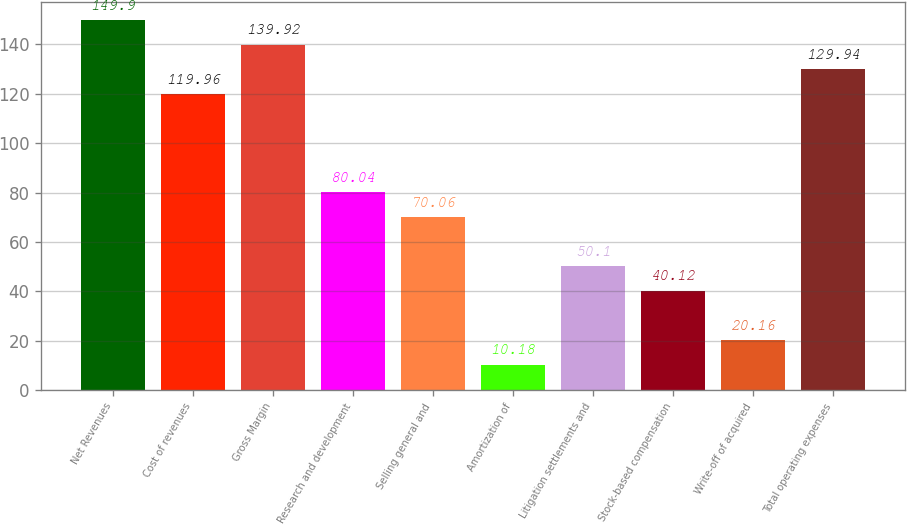Convert chart to OTSL. <chart><loc_0><loc_0><loc_500><loc_500><bar_chart><fcel>Net Revenues<fcel>Cost of revenues<fcel>Gross Margin<fcel>Research and development<fcel>Selling general and<fcel>Amortization of<fcel>Litigation settlements and<fcel>Stock-based compensation<fcel>Write-off of acquired<fcel>Total operating expenses<nl><fcel>149.9<fcel>119.96<fcel>139.92<fcel>80.04<fcel>70.06<fcel>10.18<fcel>50.1<fcel>40.12<fcel>20.16<fcel>129.94<nl></chart> 